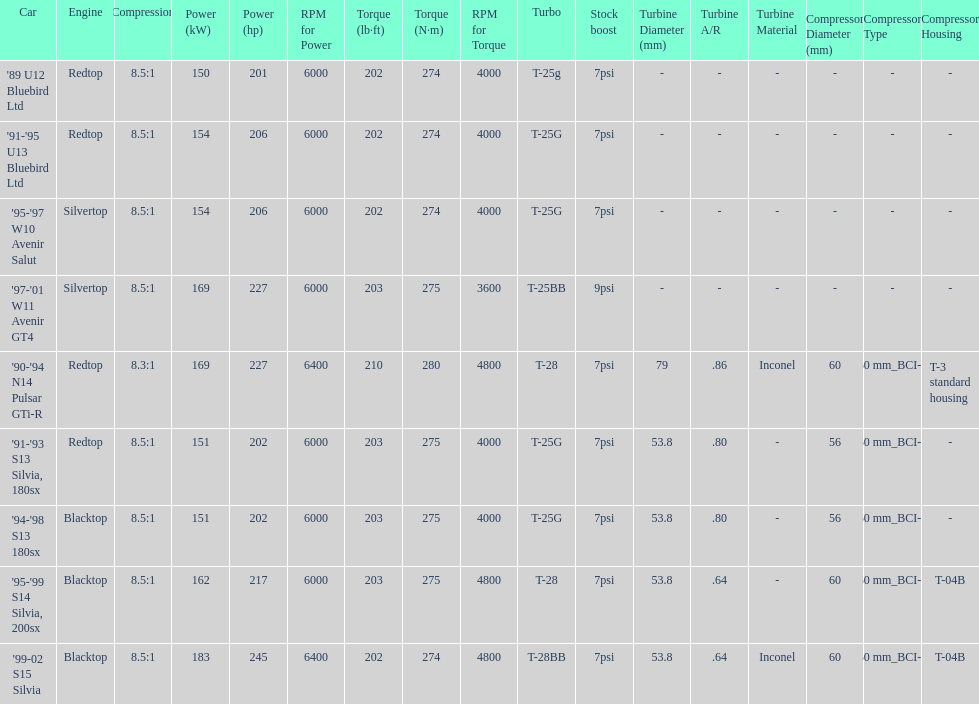What is his/her compression for the 90-94 n14 pulsar gti-r? 8.3:1. 